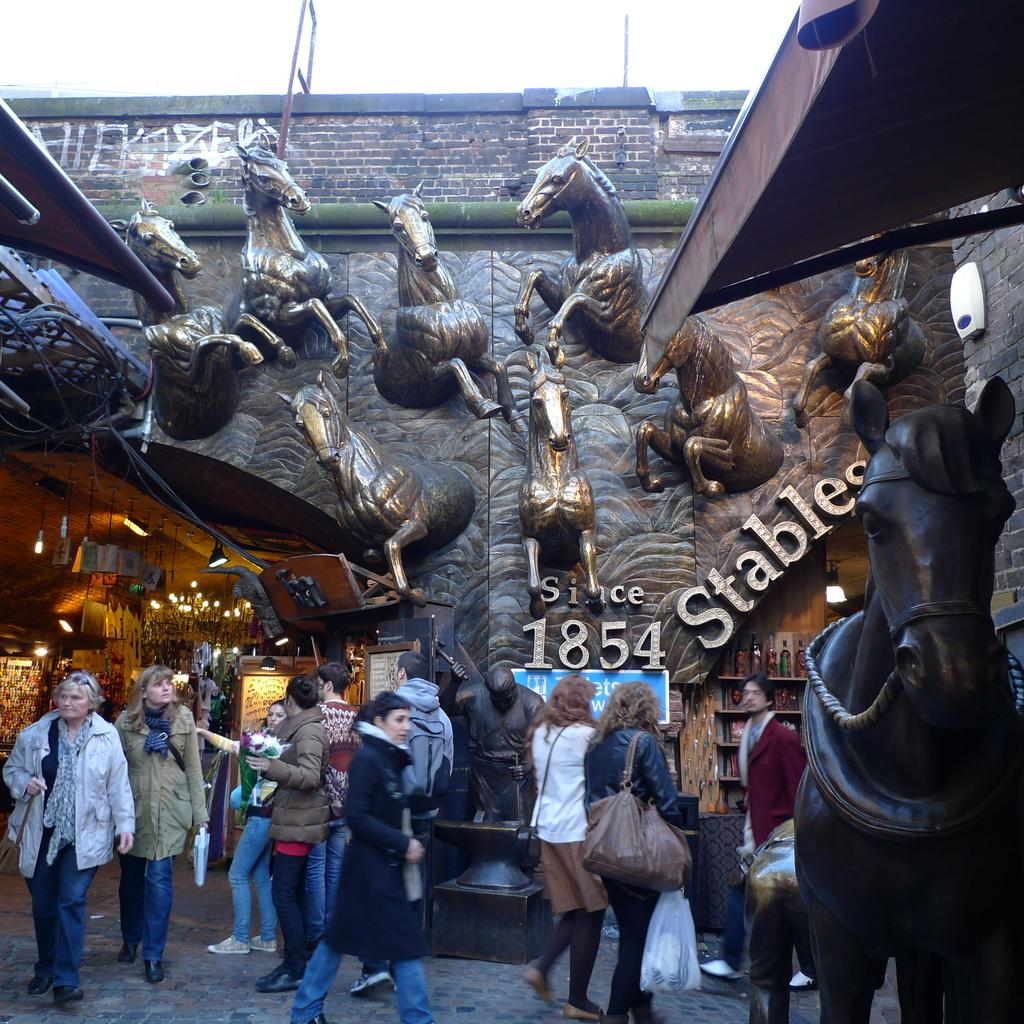Who or what can be seen at the bottom of the image? There are persons at the bottom of the image. What type of sculpture is on the right side of the image? There is a sculpture of a horse on the right side of the image. What can be seen in the background of the image? There are lights, sculptures, text, and the sky visible in the background. What type of crack can be seen in the image? There is no crack present in the image. What town is depicted in the image? The image does not depict a town; it features a sculpture of a horse and persons at the bottom. 